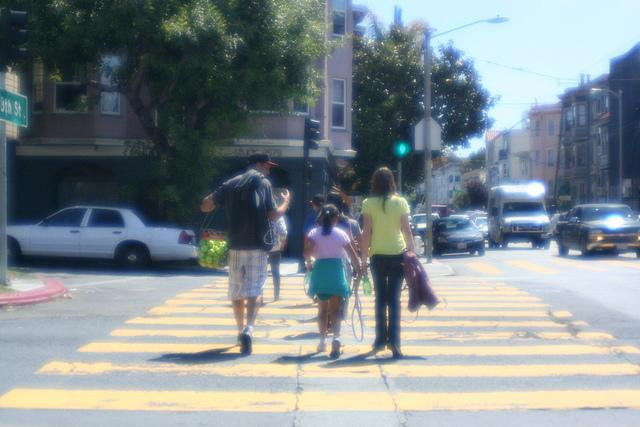How many people can be seen? Please explain your reasoning. six. There are 6. 